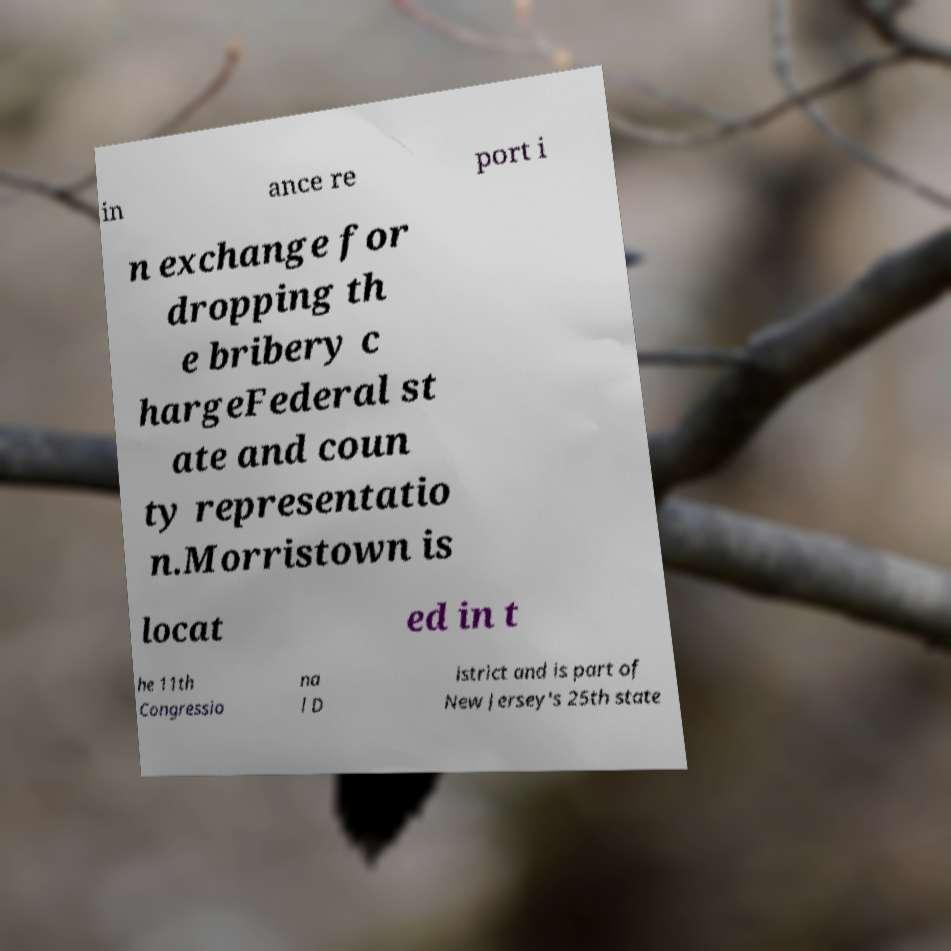For documentation purposes, I need the text within this image transcribed. Could you provide that? in ance re port i n exchange for dropping th e bribery c hargeFederal st ate and coun ty representatio n.Morristown is locat ed in t he 11th Congressio na l D istrict and is part of New Jersey's 25th state 